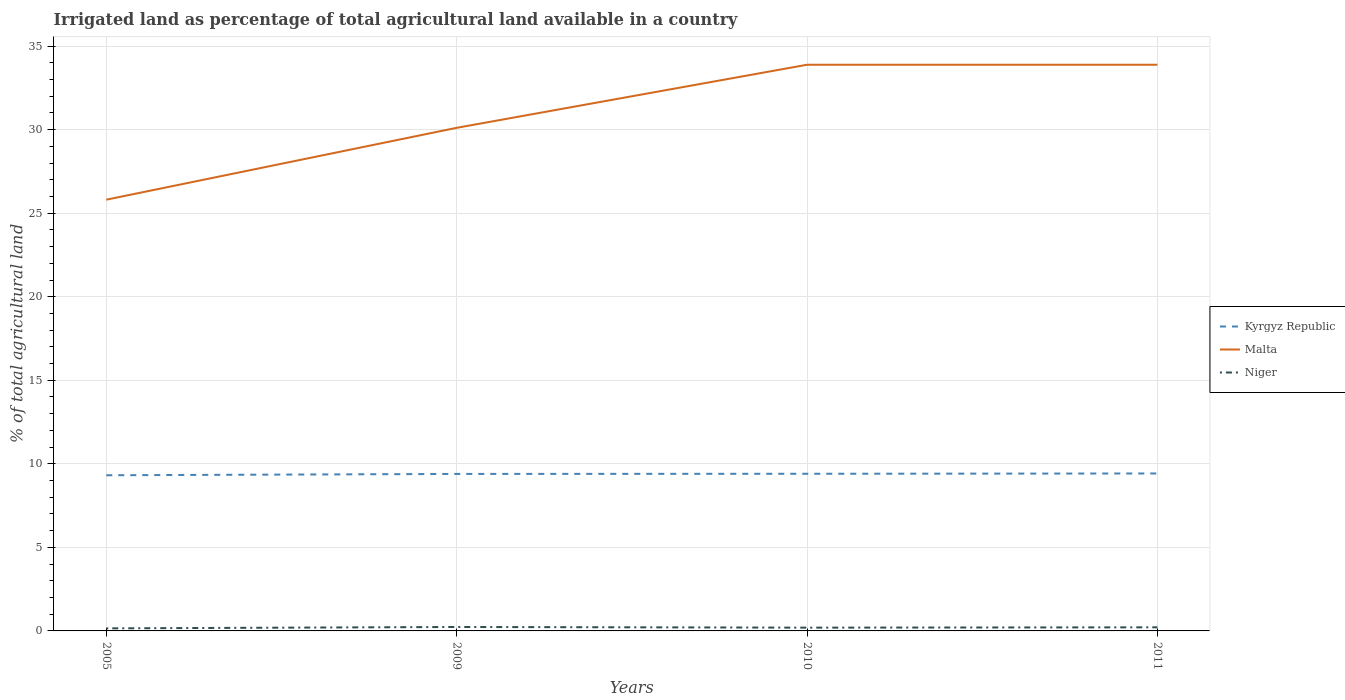How many different coloured lines are there?
Offer a very short reply. 3. Does the line corresponding to Malta intersect with the line corresponding to Niger?
Your response must be concise. No. Across all years, what is the maximum percentage of irrigated land in Kyrgyz Republic?
Your answer should be very brief. 9.32. What is the total percentage of irrigated land in Kyrgyz Republic in the graph?
Make the answer very short. -0.09. What is the difference between the highest and the second highest percentage of irrigated land in Niger?
Provide a succinct answer. 0.08. What is the difference between the highest and the lowest percentage of irrigated land in Niger?
Offer a very short reply. 2. How many years are there in the graph?
Give a very brief answer. 4. Does the graph contain grids?
Give a very brief answer. Yes. Where does the legend appear in the graph?
Your answer should be very brief. Center right. How many legend labels are there?
Offer a terse response. 3. How are the legend labels stacked?
Keep it short and to the point. Vertical. What is the title of the graph?
Offer a very short reply. Irrigated land as percentage of total agricultural land available in a country. What is the label or title of the Y-axis?
Provide a succinct answer. % of total agricultural land. What is the % of total agricultural land of Kyrgyz Republic in 2005?
Give a very brief answer. 9.32. What is the % of total agricultural land in Malta in 2005?
Make the answer very short. 25.81. What is the % of total agricultural land of Niger in 2005?
Provide a short and direct response. 0.15. What is the % of total agricultural land of Kyrgyz Republic in 2009?
Offer a terse response. 9.4. What is the % of total agricultural land in Malta in 2009?
Ensure brevity in your answer.  30.11. What is the % of total agricultural land of Niger in 2009?
Offer a very short reply. 0.24. What is the % of total agricultural land in Kyrgyz Republic in 2010?
Offer a terse response. 9.4. What is the % of total agricultural land in Malta in 2010?
Offer a terse response. 33.88. What is the % of total agricultural land of Niger in 2010?
Keep it short and to the point. 0.2. What is the % of total agricultural land in Kyrgyz Republic in 2011?
Your response must be concise. 9.42. What is the % of total agricultural land in Malta in 2011?
Your answer should be very brief. 33.88. What is the % of total agricultural land in Niger in 2011?
Provide a succinct answer. 0.21. Across all years, what is the maximum % of total agricultural land of Kyrgyz Republic?
Ensure brevity in your answer.  9.42. Across all years, what is the maximum % of total agricultural land in Malta?
Offer a very short reply. 33.88. Across all years, what is the maximum % of total agricultural land in Niger?
Give a very brief answer. 0.24. Across all years, what is the minimum % of total agricultural land of Kyrgyz Republic?
Keep it short and to the point. 9.32. Across all years, what is the minimum % of total agricultural land of Malta?
Provide a succinct answer. 25.81. Across all years, what is the minimum % of total agricultural land of Niger?
Your response must be concise. 0.15. What is the total % of total agricultural land of Kyrgyz Republic in the graph?
Your answer should be very brief. 37.54. What is the total % of total agricultural land in Malta in the graph?
Provide a short and direct response. 123.68. What is the total % of total agricultural land of Niger in the graph?
Keep it short and to the point. 0.8. What is the difference between the % of total agricultural land in Kyrgyz Republic in 2005 and that in 2009?
Your response must be concise. -0.08. What is the difference between the % of total agricultural land in Malta in 2005 and that in 2009?
Offer a very short reply. -4.3. What is the difference between the % of total agricultural land in Niger in 2005 and that in 2009?
Make the answer very short. -0.08. What is the difference between the % of total agricultural land in Kyrgyz Republic in 2005 and that in 2010?
Your response must be concise. -0.09. What is the difference between the % of total agricultural land of Malta in 2005 and that in 2010?
Your answer should be compact. -8.08. What is the difference between the % of total agricultural land of Niger in 2005 and that in 2010?
Your answer should be very brief. -0.04. What is the difference between the % of total agricultural land of Kyrgyz Republic in 2005 and that in 2011?
Make the answer very short. -0.11. What is the difference between the % of total agricultural land of Malta in 2005 and that in 2011?
Give a very brief answer. -8.08. What is the difference between the % of total agricultural land in Niger in 2005 and that in 2011?
Your answer should be compact. -0.06. What is the difference between the % of total agricultural land of Kyrgyz Republic in 2009 and that in 2010?
Offer a terse response. -0.01. What is the difference between the % of total agricultural land of Malta in 2009 and that in 2010?
Make the answer very short. -3.77. What is the difference between the % of total agricultural land of Niger in 2009 and that in 2010?
Give a very brief answer. 0.04. What is the difference between the % of total agricultural land in Kyrgyz Republic in 2009 and that in 2011?
Keep it short and to the point. -0.03. What is the difference between the % of total agricultural land in Malta in 2009 and that in 2011?
Give a very brief answer. -3.77. What is the difference between the % of total agricultural land of Niger in 2009 and that in 2011?
Keep it short and to the point. 0.02. What is the difference between the % of total agricultural land of Kyrgyz Republic in 2010 and that in 2011?
Your answer should be compact. -0.02. What is the difference between the % of total agricultural land in Malta in 2010 and that in 2011?
Offer a very short reply. 0. What is the difference between the % of total agricultural land of Niger in 2010 and that in 2011?
Provide a short and direct response. -0.02. What is the difference between the % of total agricultural land of Kyrgyz Republic in 2005 and the % of total agricultural land of Malta in 2009?
Provide a succinct answer. -20.79. What is the difference between the % of total agricultural land of Kyrgyz Republic in 2005 and the % of total agricultural land of Niger in 2009?
Your answer should be compact. 9.08. What is the difference between the % of total agricultural land in Malta in 2005 and the % of total agricultural land in Niger in 2009?
Offer a very short reply. 25.57. What is the difference between the % of total agricultural land of Kyrgyz Republic in 2005 and the % of total agricultural land of Malta in 2010?
Provide a short and direct response. -24.57. What is the difference between the % of total agricultural land of Kyrgyz Republic in 2005 and the % of total agricultural land of Niger in 2010?
Keep it short and to the point. 9.12. What is the difference between the % of total agricultural land of Malta in 2005 and the % of total agricultural land of Niger in 2010?
Provide a short and direct response. 25.61. What is the difference between the % of total agricultural land of Kyrgyz Republic in 2005 and the % of total agricultural land of Malta in 2011?
Your response must be concise. -24.57. What is the difference between the % of total agricultural land in Kyrgyz Republic in 2005 and the % of total agricultural land in Niger in 2011?
Keep it short and to the point. 9.1. What is the difference between the % of total agricultural land in Malta in 2005 and the % of total agricultural land in Niger in 2011?
Give a very brief answer. 25.59. What is the difference between the % of total agricultural land in Kyrgyz Republic in 2009 and the % of total agricultural land in Malta in 2010?
Ensure brevity in your answer.  -24.49. What is the difference between the % of total agricultural land in Kyrgyz Republic in 2009 and the % of total agricultural land in Niger in 2010?
Your answer should be compact. 9.2. What is the difference between the % of total agricultural land of Malta in 2009 and the % of total agricultural land of Niger in 2010?
Provide a succinct answer. 29.91. What is the difference between the % of total agricultural land in Kyrgyz Republic in 2009 and the % of total agricultural land in Malta in 2011?
Provide a succinct answer. -24.49. What is the difference between the % of total agricultural land of Kyrgyz Republic in 2009 and the % of total agricultural land of Niger in 2011?
Ensure brevity in your answer.  9.18. What is the difference between the % of total agricultural land of Malta in 2009 and the % of total agricultural land of Niger in 2011?
Keep it short and to the point. 29.89. What is the difference between the % of total agricultural land in Kyrgyz Republic in 2010 and the % of total agricultural land in Malta in 2011?
Offer a very short reply. -24.48. What is the difference between the % of total agricultural land in Kyrgyz Republic in 2010 and the % of total agricultural land in Niger in 2011?
Make the answer very short. 9.19. What is the difference between the % of total agricultural land in Malta in 2010 and the % of total agricultural land in Niger in 2011?
Provide a short and direct response. 33.67. What is the average % of total agricultural land in Kyrgyz Republic per year?
Provide a short and direct response. 9.38. What is the average % of total agricultural land of Malta per year?
Ensure brevity in your answer.  30.92. What is the average % of total agricultural land in Niger per year?
Your response must be concise. 0.2. In the year 2005, what is the difference between the % of total agricultural land in Kyrgyz Republic and % of total agricultural land in Malta?
Make the answer very short. -16.49. In the year 2005, what is the difference between the % of total agricultural land in Kyrgyz Republic and % of total agricultural land in Niger?
Your response must be concise. 9.16. In the year 2005, what is the difference between the % of total agricultural land of Malta and % of total agricultural land of Niger?
Your response must be concise. 25.65. In the year 2009, what is the difference between the % of total agricultural land in Kyrgyz Republic and % of total agricultural land in Malta?
Ensure brevity in your answer.  -20.71. In the year 2009, what is the difference between the % of total agricultural land in Kyrgyz Republic and % of total agricultural land in Niger?
Offer a very short reply. 9.16. In the year 2009, what is the difference between the % of total agricultural land of Malta and % of total agricultural land of Niger?
Give a very brief answer. 29.87. In the year 2010, what is the difference between the % of total agricultural land in Kyrgyz Republic and % of total agricultural land in Malta?
Provide a succinct answer. -24.48. In the year 2010, what is the difference between the % of total agricultural land of Kyrgyz Republic and % of total agricultural land of Niger?
Ensure brevity in your answer.  9.21. In the year 2010, what is the difference between the % of total agricultural land of Malta and % of total agricultural land of Niger?
Your response must be concise. 33.69. In the year 2011, what is the difference between the % of total agricultural land of Kyrgyz Republic and % of total agricultural land of Malta?
Offer a terse response. -24.46. In the year 2011, what is the difference between the % of total agricultural land in Kyrgyz Republic and % of total agricultural land in Niger?
Provide a succinct answer. 9.21. In the year 2011, what is the difference between the % of total agricultural land in Malta and % of total agricultural land in Niger?
Offer a terse response. 33.67. What is the ratio of the % of total agricultural land in Niger in 2005 to that in 2009?
Your answer should be very brief. 0.65. What is the ratio of the % of total agricultural land of Kyrgyz Republic in 2005 to that in 2010?
Keep it short and to the point. 0.99. What is the ratio of the % of total agricultural land of Malta in 2005 to that in 2010?
Offer a terse response. 0.76. What is the ratio of the % of total agricultural land of Niger in 2005 to that in 2010?
Provide a succinct answer. 0.78. What is the ratio of the % of total agricultural land of Kyrgyz Republic in 2005 to that in 2011?
Offer a terse response. 0.99. What is the ratio of the % of total agricultural land of Malta in 2005 to that in 2011?
Your answer should be compact. 0.76. What is the ratio of the % of total agricultural land in Niger in 2005 to that in 2011?
Give a very brief answer. 0.71. What is the ratio of the % of total agricultural land of Kyrgyz Republic in 2009 to that in 2010?
Provide a succinct answer. 1. What is the ratio of the % of total agricultural land of Malta in 2009 to that in 2010?
Offer a terse response. 0.89. What is the ratio of the % of total agricultural land in Niger in 2009 to that in 2010?
Provide a short and direct response. 1.21. What is the ratio of the % of total agricultural land of Kyrgyz Republic in 2009 to that in 2011?
Keep it short and to the point. 1. What is the ratio of the % of total agricultural land in Malta in 2009 to that in 2011?
Offer a terse response. 0.89. What is the ratio of the % of total agricultural land of Niger in 2009 to that in 2011?
Your response must be concise. 1.1. What is the ratio of the % of total agricultural land in Niger in 2010 to that in 2011?
Keep it short and to the point. 0.91. What is the difference between the highest and the second highest % of total agricultural land of Kyrgyz Republic?
Provide a short and direct response. 0.02. What is the difference between the highest and the second highest % of total agricultural land of Malta?
Your response must be concise. 0. What is the difference between the highest and the second highest % of total agricultural land of Niger?
Provide a short and direct response. 0.02. What is the difference between the highest and the lowest % of total agricultural land in Kyrgyz Republic?
Give a very brief answer. 0.11. What is the difference between the highest and the lowest % of total agricultural land of Malta?
Keep it short and to the point. 8.08. What is the difference between the highest and the lowest % of total agricultural land in Niger?
Make the answer very short. 0.08. 